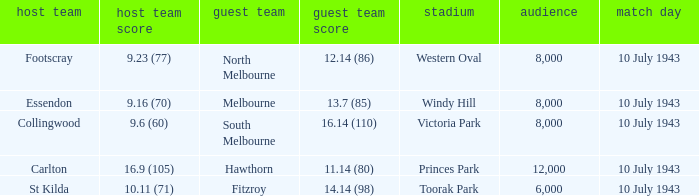When the Venue was victoria park, what was the Away team score? 16.14 (110). 